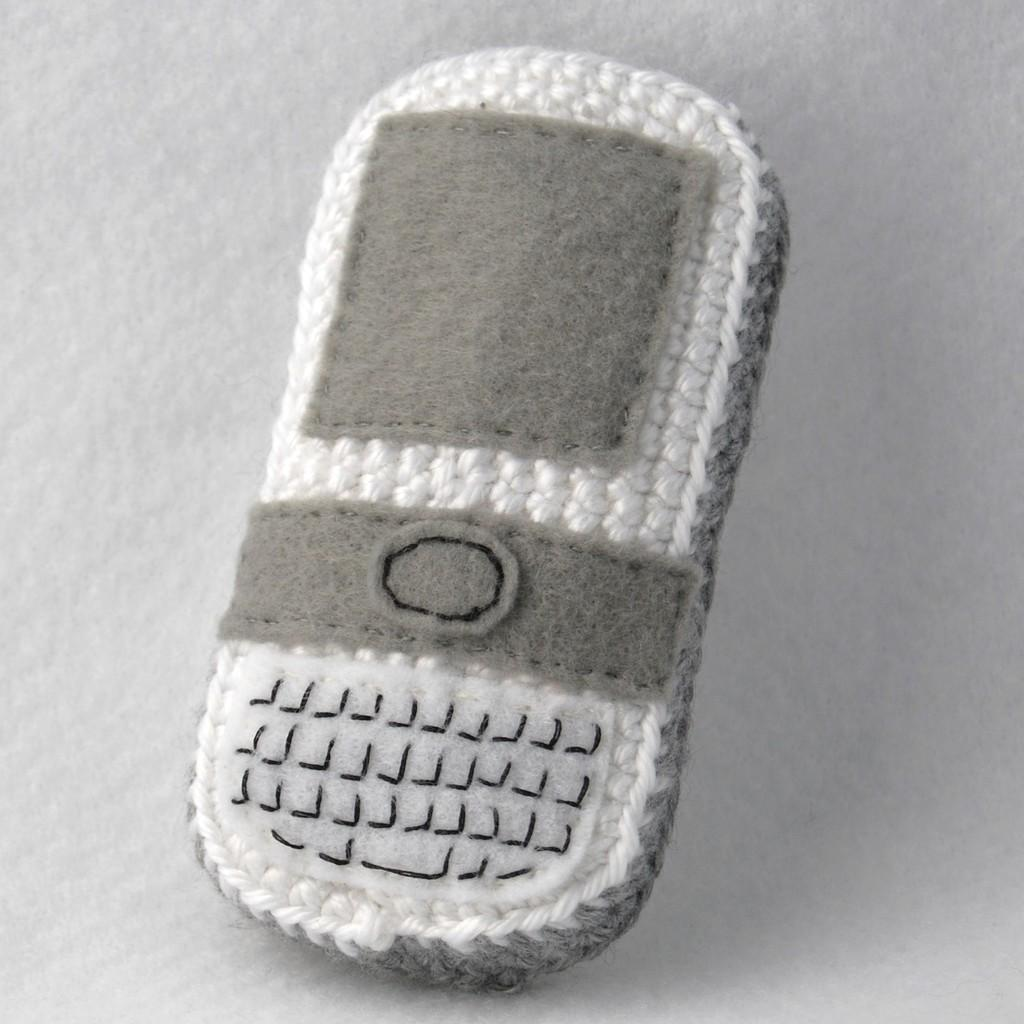What object is the main subject of the image? There is a mobile in the image. What material is the mobile is made of? The mobile is made with wool. What color is the background of the image? The background of the image is white. What type of pail is used to collect water in the image? There is no pail present in the image; it only features a mobile made with wool against a white background. 